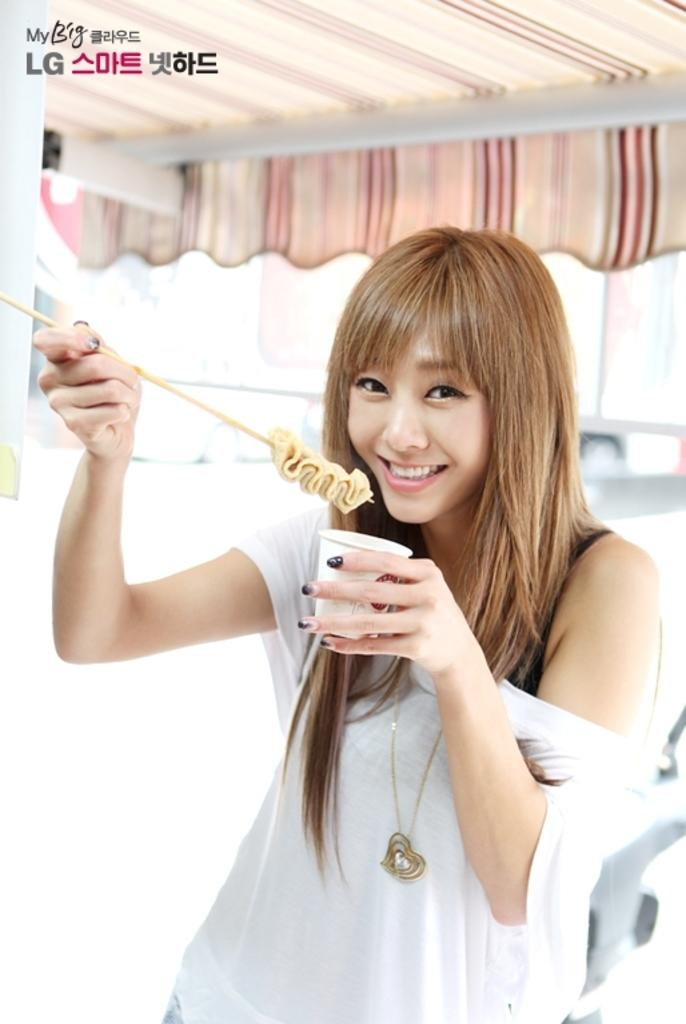What is the person in the image doing? The person is standing in the image and holding a glass and a stick. What is the person wearing? The person is wearing a white color dress. What can be seen in the background of the image? There is a tent in the background. What colors are visible on the tent? The tent has peach and white colors. Is there a rainstorm happening inside the cave in the image? There is no cave or rainstorm present in the image. Can you tell me how many drawers are visible in the image? There are no drawers visible in the image. 